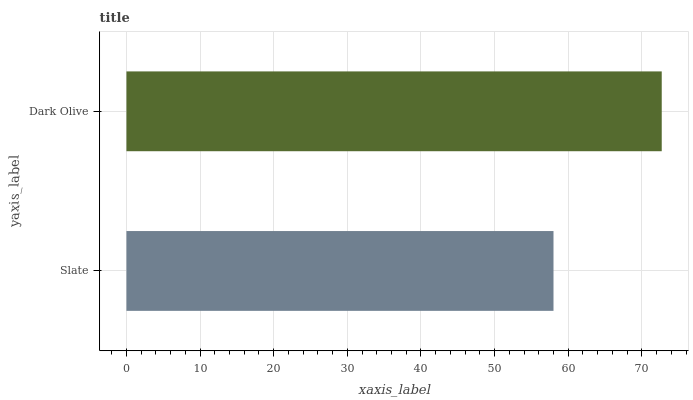Is Slate the minimum?
Answer yes or no. Yes. Is Dark Olive the maximum?
Answer yes or no. Yes. Is Dark Olive the minimum?
Answer yes or no. No. Is Dark Olive greater than Slate?
Answer yes or no. Yes. Is Slate less than Dark Olive?
Answer yes or no. Yes. Is Slate greater than Dark Olive?
Answer yes or no. No. Is Dark Olive less than Slate?
Answer yes or no. No. Is Dark Olive the high median?
Answer yes or no. Yes. Is Slate the low median?
Answer yes or no. Yes. Is Slate the high median?
Answer yes or no. No. Is Dark Olive the low median?
Answer yes or no. No. 